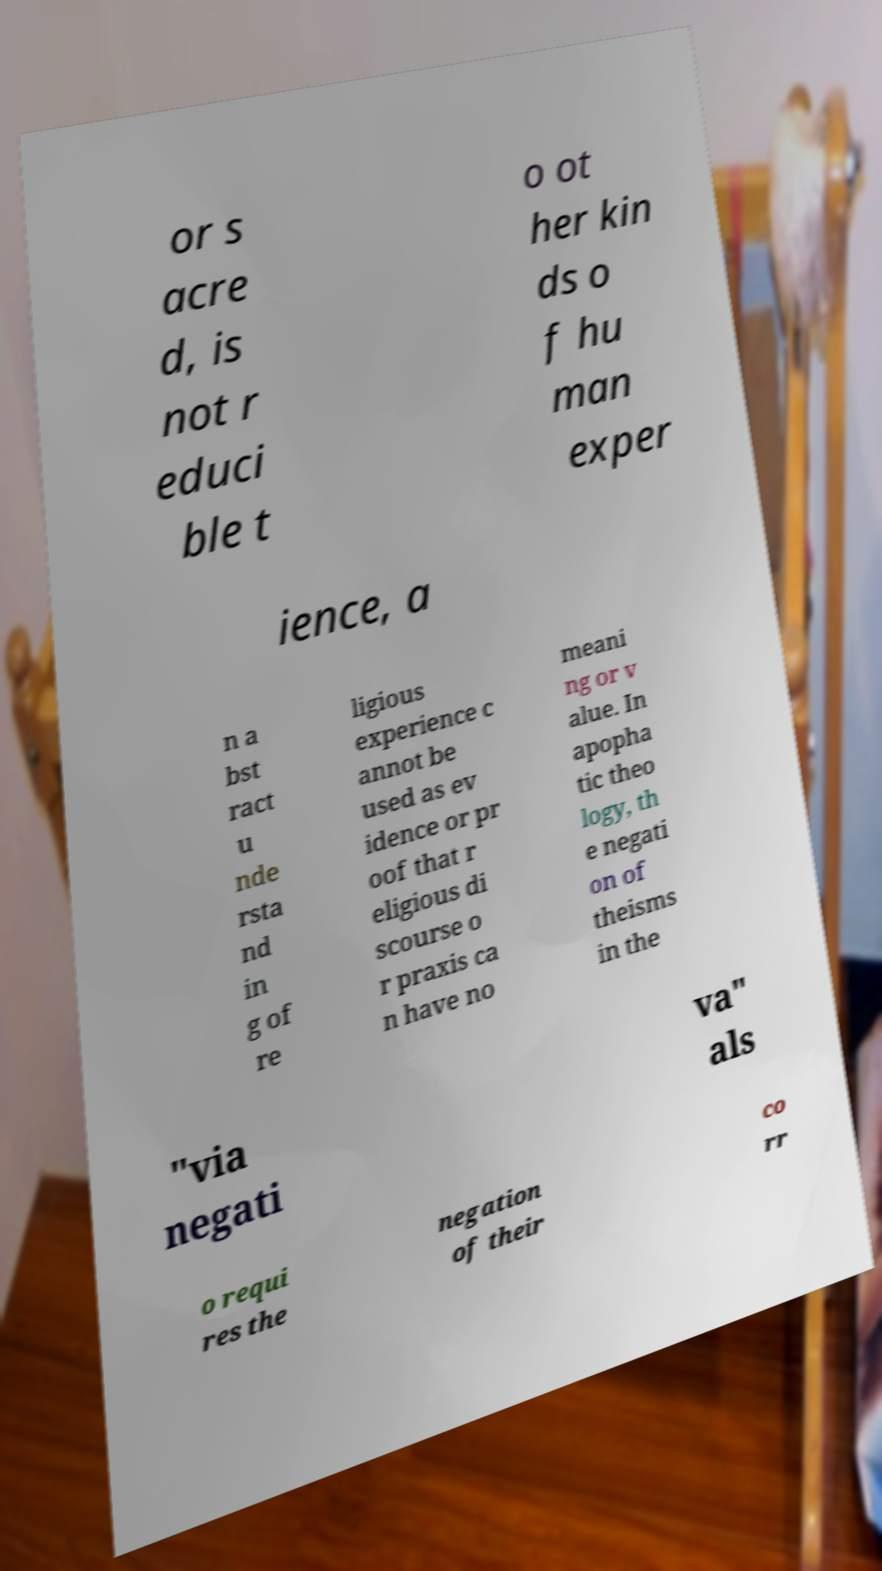For documentation purposes, I need the text within this image transcribed. Could you provide that? or s acre d, is not r educi ble t o ot her kin ds o f hu man exper ience, a n a bst ract u nde rsta nd in g of re ligious experience c annot be used as ev idence or pr oof that r eligious di scourse o r praxis ca n have no meani ng or v alue. In apopha tic theo logy, th e negati on of theisms in the "via negati va" als o requi res the negation of their co rr 